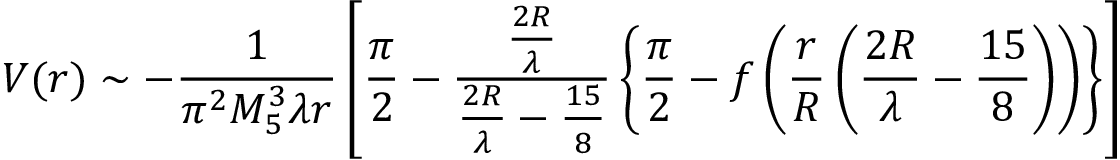Convert formula to latex. <formula><loc_0><loc_0><loc_500><loc_500>V ( r ) \sim - \frac { 1 } { \pi ^ { 2 } M _ { 5 } ^ { 3 } \lambda r } \left [ \frac { \pi } { 2 } - \frac { \frac { 2 R } { \lambda } } { \frac { 2 R } { \lambda } - \frac { 1 5 } { 8 } } \left \{ \frac { \pi } { 2 } - f \left ( \frac { r } { R } \left ( \frac { 2 R } { \lambda } - \frac { 1 5 } { 8 } \right ) \right ) \right \} \right ]</formula> 